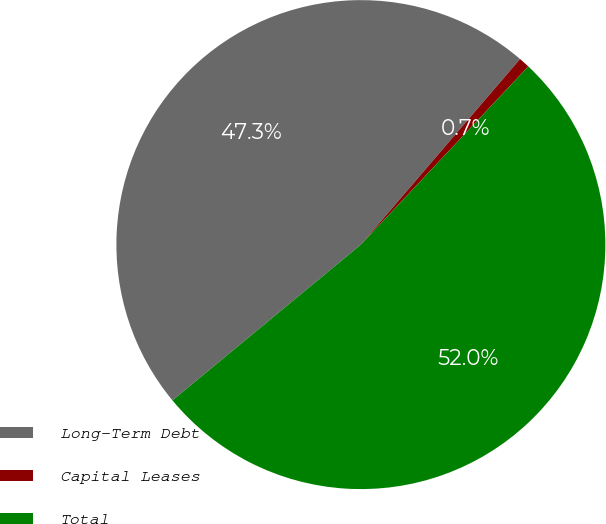Convert chart. <chart><loc_0><loc_0><loc_500><loc_500><pie_chart><fcel>Long-Term Debt<fcel>Capital Leases<fcel>Total<nl><fcel>47.28%<fcel>0.72%<fcel>52.0%<nl></chart> 